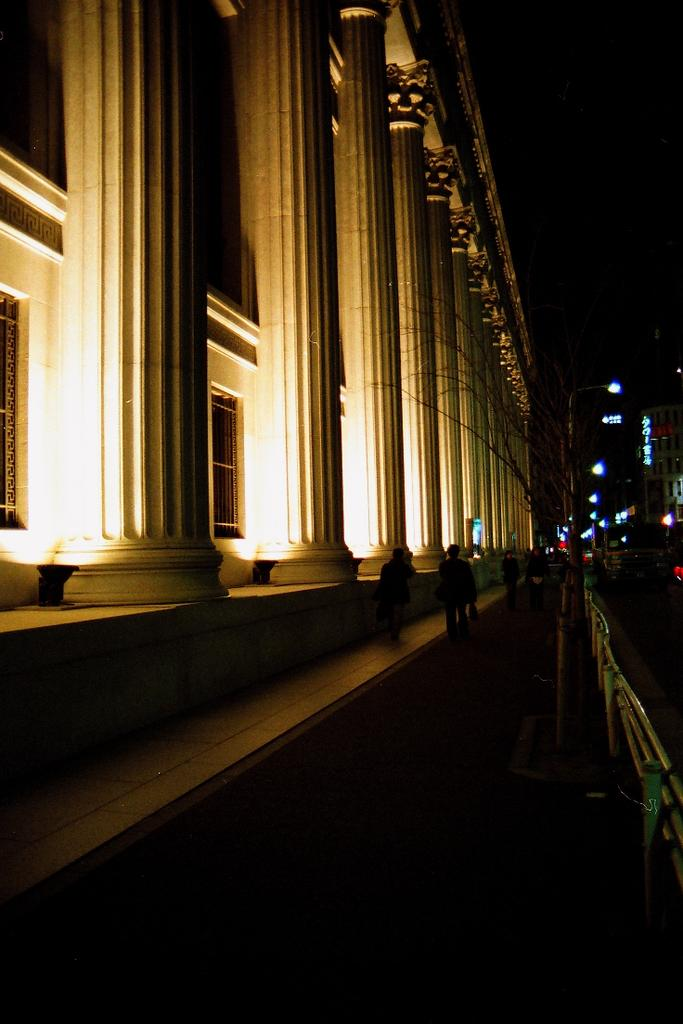How many people are in the image? There are people in the image, but the exact number is not specified. What is the purpose of the fence in the image? The purpose of the fence in the image is not clear, but it could be for enclosing an area or providing a boundary. What are the lights in the image used for? A: The purpose of the lights in the image is not specified, but they could be for illumination or decoration. What are the poles in the image used for? The purpose of the poles in the image is not specified, but they could be for supporting structures or holding signs. What are the pillars in the image used for? The purpose of the pillars in the image is not specified, but they could be for supporting structures or providing architectural detail. What type of structures are visible in the image? There are buildings in the image, but their specific type or purpose is not specified. What is the color of the background in the image? The background of the image is dark, but the exact color is not specified. What type of school can be seen in the image? There is no school present in the image. What is the governor doing in the image? There is no governor present in the image. 